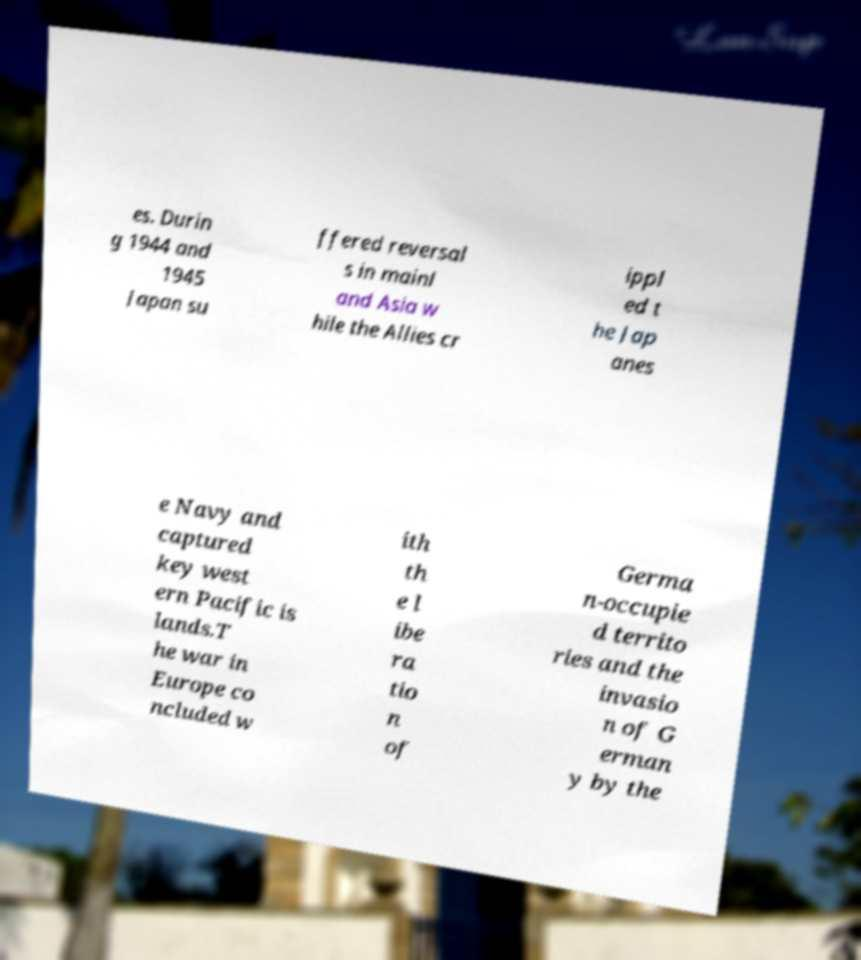Can you read and provide the text displayed in the image?This photo seems to have some interesting text. Can you extract and type it out for me? es. Durin g 1944 and 1945 Japan su ffered reversal s in mainl and Asia w hile the Allies cr ippl ed t he Jap anes e Navy and captured key west ern Pacific is lands.T he war in Europe co ncluded w ith th e l ibe ra tio n of Germa n-occupie d territo ries and the invasio n of G erman y by the 